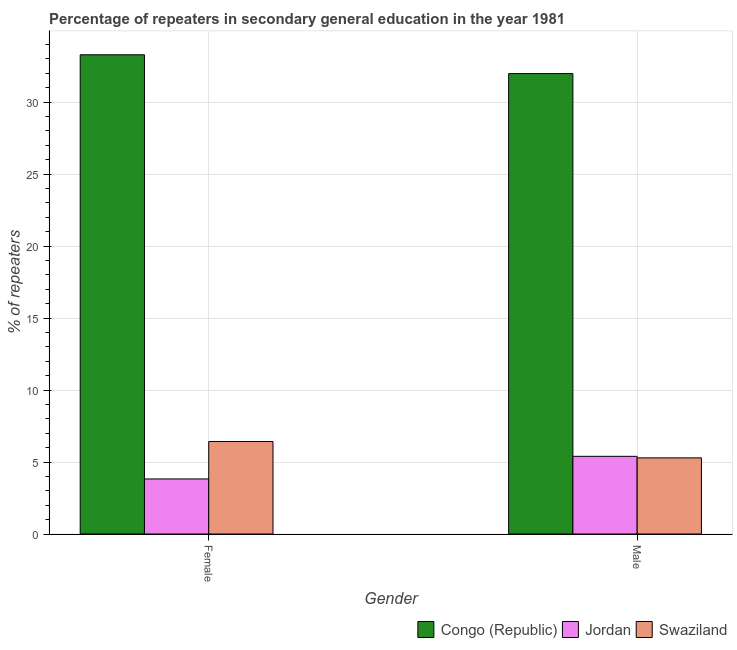How many different coloured bars are there?
Provide a short and direct response. 3. Are the number of bars per tick equal to the number of legend labels?
Give a very brief answer. Yes. Are the number of bars on each tick of the X-axis equal?
Your response must be concise. Yes. What is the label of the 1st group of bars from the left?
Your answer should be very brief. Female. What is the percentage of female repeaters in Congo (Republic)?
Keep it short and to the point. 33.29. Across all countries, what is the maximum percentage of male repeaters?
Provide a short and direct response. 31.98. Across all countries, what is the minimum percentage of male repeaters?
Your answer should be very brief. 5.29. In which country was the percentage of male repeaters maximum?
Provide a succinct answer. Congo (Republic). In which country was the percentage of male repeaters minimum?
Give a very brief answer. Swaziland. What is the total percentage of female repeaters in the graph?
Your response must be concise. 43.54. What is the difference between the percentage of male repeaters in Jordan and that in Swaziland?
Give a very brief answer. 0.11. What is the difference between the percentage of male repeaters in Jordan and the percentage of female repeaters in Congo (Republic)?
Keep it short and to the point. -27.9. What is the average percentage of male repeaters per country?
Provide a succinct answer. 14.22. What is the difference between the percentage of female repeaters and percentage of male repeaters in Swaziland?
Offer a terse response. 1.14. What is the ratio of the percentage of male repeaters in Swaziland to that in Congo (Republic)?
Give a very brief answer. 0.17. Is the percentage of male repeaters in Jordan less than that in Congo (Republic)?
Make the answer very short. Yes. What does the 1st bar from the left in Male represents?
Offer a terse response. Congo (Republic). What does the 3rd bar from the right in Male represents?
Provide a short and direct response. Congo (Republic). What is the difference between two consecutive major ticks on the Y-axis?
Offer a terse response. 5. Are the values on the major ticks of Y-axis written in scientific E-notation?
Offer a very short reply. No. Does the graph contain any zero values?
Give a very brief answer. No. How many legend labels are there?
Keep it short and to the point. 3. How are the legend labels stacked?
Your answer should be very brief. Horizontal. What is the title of the graph?
Ensure brevity in your answer.  Percentage of repeaters in secondary general education in the year 1981. What is the label or title of the X-axis?
Give a very brief answer. Gender. What is the label or title of the Y-axis?
Provide a succinct answer. % of repeaters. What is the % of repeaters of Congo (Republic) in Female?
Provide a short and direct response. 33.29. What is the % of repeaters of Jordan in Female?
Offer a very short reply. 3.82. What is the % of repeaters in Swaziland in Female?
Your answer should be very brief. 6.42. What is the % of repeaters in Congo (Republic) in Male?
Make the answer very short. 31.98. What is the % of repeaters in Jordan in Male?
Provide a short and direct response. 5.4. What is the % of repeaters of Swaziland in Male?
Provide a succinct answer. 5.29. Across all Gender, what is the maximum % of repeaters of Congo (Republic)?
Make the answer very short. 33.29. Across all Gender, what is the maximum % of repeaters in Jordan?
Your answer should be compact. 5.4. Across all Gender, what is the maximum % of repeaters in Swaziland?
Provide a succinct answer. 6.42. Across all Gender, what is the minimum % of repeaters of Congo (Republic)?
Offer a very short reply. 31.98. Across all Gender, what is the minimum % of repeaters in Jordan?
Your response must be concise. 3.82. Across all Gender, what is the minimum % of repeaters in Swaziland?
Your response must be concise. 5.29. What is the total % of repeaters in Congo (Republic) in the graph?
Ensure brevity in your answer.  65.27. What is the total % of repeaters of Jordan in the graph?
Your response must be concise. 9.22. What is the total % of repeaters in Swaziland in the graph?
Make the answer very short. 11.71. What is the difference between the % of repeaters in Congo (Republic) in Female and that in Male?
Your answer should be very brief. 1.31. What is the difference between the % of repeaters in Jordan in Female and that in Male?
Ensure brevity in your answer.  -1.57. What is the difference between the % of repeaters of Swaziland in Female and that in Male?
Ensure brevity in your answer.  1.14. What is the difference between the % of repeaters of Congo (Republic) in Female and the % of repeaters of Jordan in Male?
Keep it short and to the point. 27.9. What is the difference between the % of repeaters in Congo (Republic) in Female and the % of repeaters in Swaziland in Male?
Give a very brief answer. 28. What is the difference between the % of repeaters in Jordan in Female and the % of repeaters in Swaziland in Male?
Give a very brief answer. -1.46. What is the average % of repeaters in Congo (Republic) per Gender?
Give a very brief answer. 32.64. What is the average % of repeaters in Jordan per Gender?
Keep it short and to the point. 4.61. What is the average % of repeaters of Swaziland per Gender?
Offer a very short reply. 5.86. What is the difference between the % of repeaters in Congo (Republic) and % of repeaters in Jordan in Female?
Make the answer very short. 29.47. What is the difference between the % of repeaters of Congo (Republic) and % of repeaters of Swaziland in Female?
Provide a short and direct response. 26.87. What is the difference between the % of repeaters of Congo (Republic) and % of repeaters of Jordan in Male?
Provide a succinct answer. 26.59. What is the difference between the % of repeaters of Congo (Republic) and % of repeaters of Swaziland in Male?
Offer a very short reply. 26.69. What is the difference between the % of repeaters in Jordan and % of repeaters in Swaziland in Male?
Give a very brief answer. 0.11. What is the ratio of the % of repeaters in Congo (Republic) in Female to that in Male?
Provide a short and direct response. 1.04. What is the ratio of the % of repeaters in Jordan in Female to that in Male?
Offer a very short reply. 0.71. What is the ratio of the % of repeaters in Swaziland in Female to that in Male?
Ensure brevity in your answer.  1.21. What is the difference between the highest and the second highest % of repeaters in Congo (Republic)?
Keep it short and to the point. 1.31. What is the difference between the highest and the second highest % of repeaters of Jordan?
Your response must be concise. 1.57. What is the difference between the highest and the second highest % of repeaters of Swaziland?
Keep it short and to the point. 1.14. What is the difference between the highest and the lowest % of repeaters of Congo (Republic)?
Provide a short and direct response. 1.31. What is the difference between the highest and the lowest % of repeaters in Jordan?
Your response must be concise. 1.57. What is the difference between the highest and the lowest % of repeaters in Swaziland?
Your answer should be compact. 1.14. 